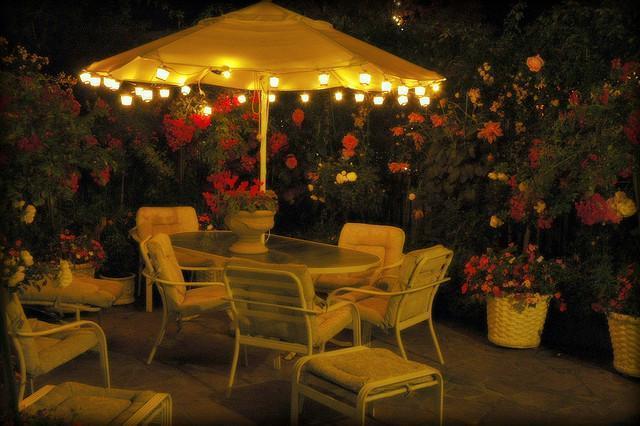How many chairs are visible?
Give a very brief answer. 8. How many potted plants are in the picture?
Give a very brief answer. 5. 